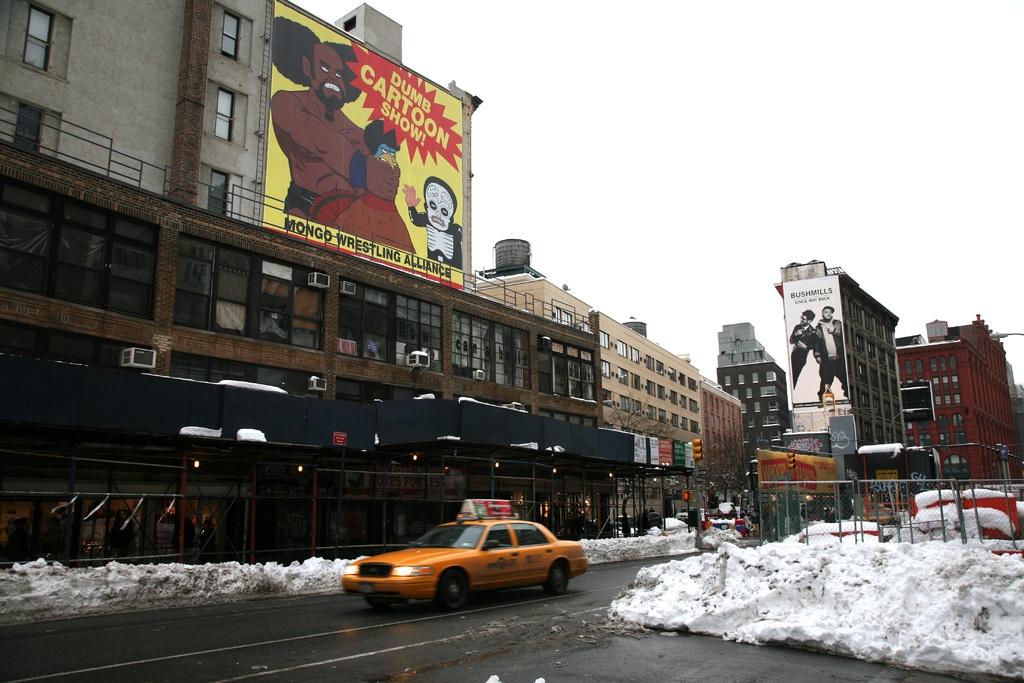What moving is showing near you?
Provide a short and direct response. Dumb cartoon show. What kind of cartoon show?
Provide a succinct answer. Dumb. 